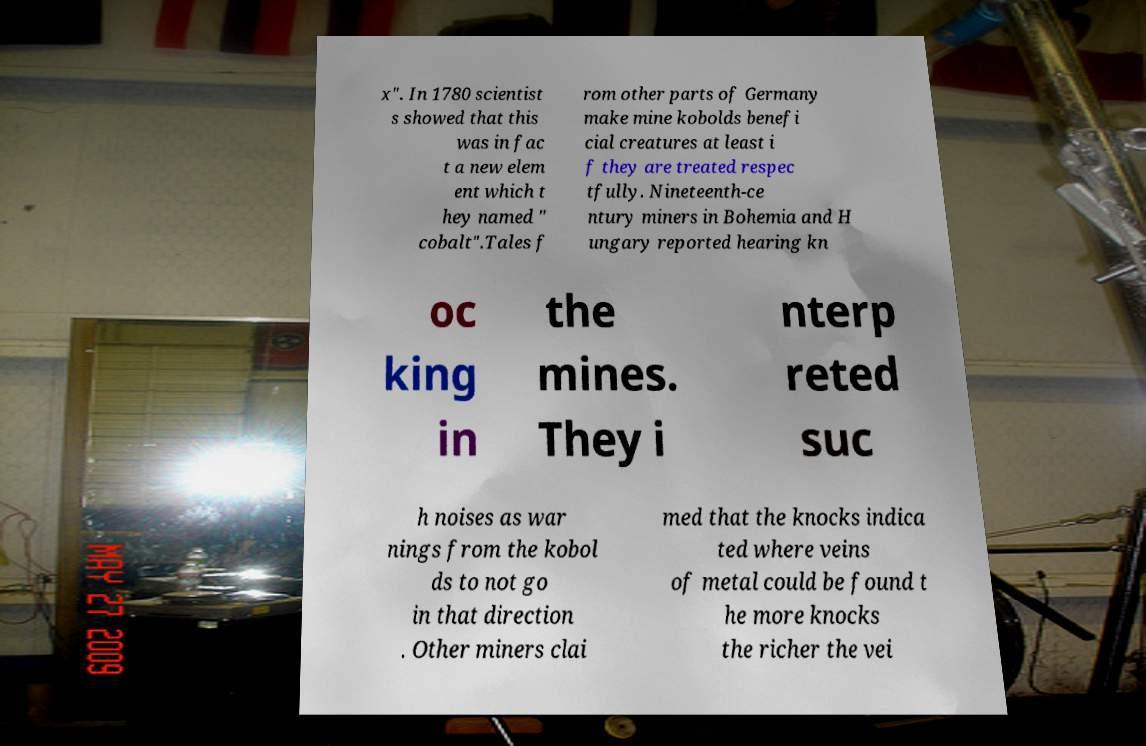Please identify and transcribe the text found in this image. x". In 1780 scientist s showed that this was in fac t a new elem ent which t hey named " cobalt".Tales f rom other parts of Germany make mine kobolds benefi cial creatures at least i f they are treated respec tfully. Nineteenth-ce ntury miners in Bohemia and H ungary reported hearing kn oc king in the mines. They i nterp reted suc h noises as war nings from the kobol ds to not go in that direction . Other miners clai med that the knocks indica ted where veins of metal could be found t he more knocks the richer the vei 